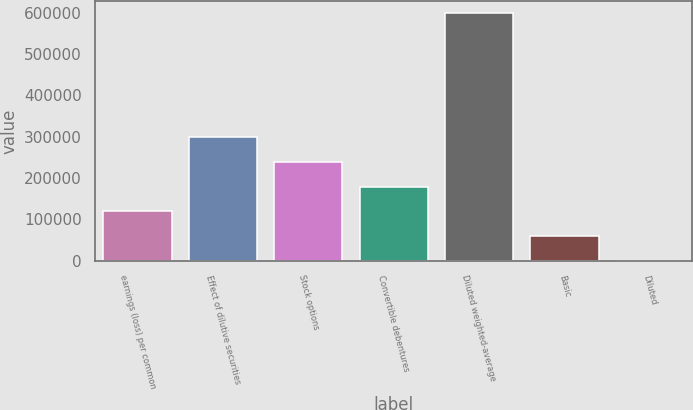Convert chart. <chart><loc_0><loc_0><loc_500><loc_500><bar_chart><fcel>earnings (loss) per common<fcel>Effect of dilutive securities<fcel>Stock options<fcel>Convertible debentures<fcel>Diluted weighted-average<fcel>Basic<fcel>Diluted<nl><fcel>119636<fcel>299088<fcel>239271<fcel>179453<fcel>598175<fcel>59818.7<fcel>1.34<nl></chart> 